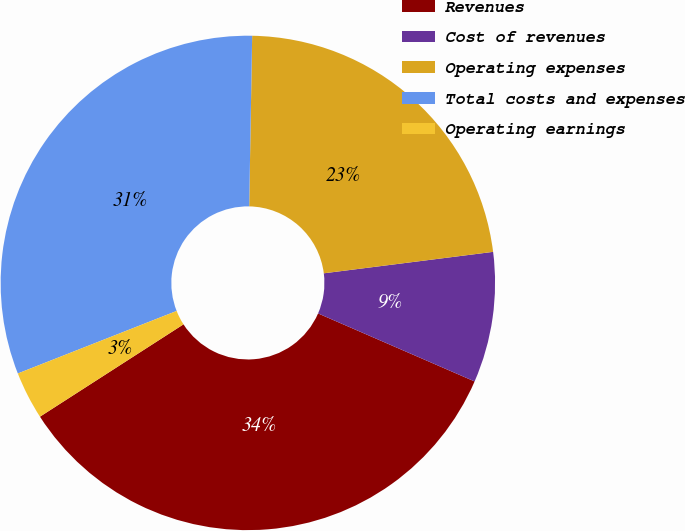Convert chart. <chart><loc_0><loc_0><loc_500><loc_500><pie_chart><fcel>Revenues<fcel>Cost of revenues<fcel>Operating expenses<fcel>Total costs and expenses<fcel>Operating earnings<nl><fcel>34.38%<fcel>8.53%<fcel>22.72%<fcel>31.25%<fcel>3.13%<nl></chart> 